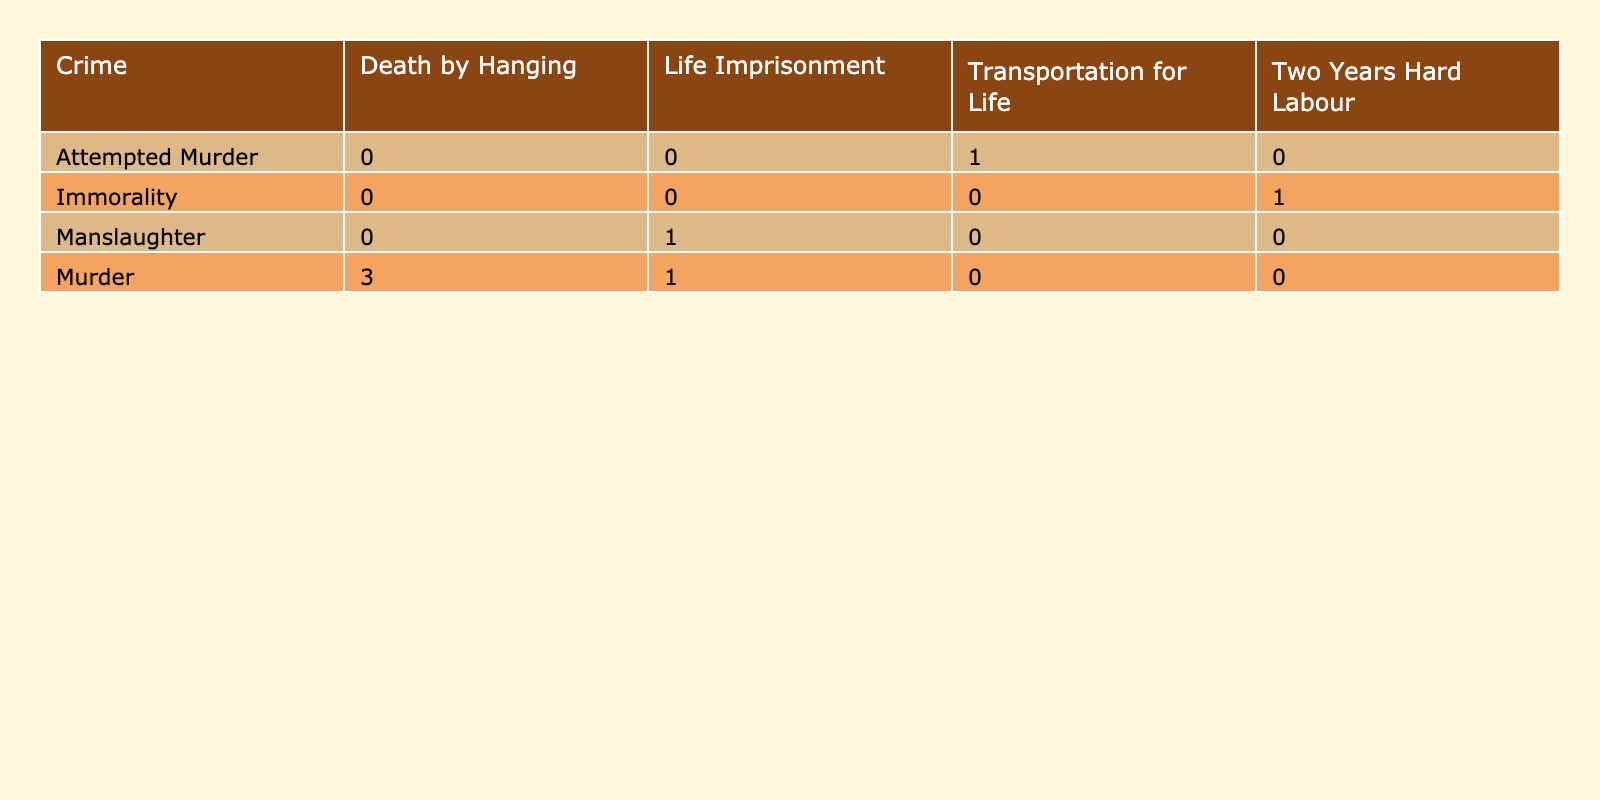What was the sentencing outcome for the murder trial of Dr. Hawley Crippen? The table shows that Dr. Hawley Crippen was found guilty of murder in 1910 and received the sentencing outcome of "Death by Hanging."
Answer: Death by Hanging How many defendants were sentenced to imprisonment for life? There are two defendants in the table who were sentenced to life imprisonment: George Wainwright and Florence Maybrick. Thus, the count is 2.
Answer: 2 Did any defendant receive transportation for life? By examining the table, it is evident that William Wainwright was sentenced to "Transportation for Life." Therefore, the answer is yes.
Answer: Yes What percentage of the crimes listed resulted in a death sentence? Of the eight trials listed, three resulted in a death sentence (Dr. Hawley Crippen, George Joseph Smith, Edward O'Neill). The percentage is calculated as (3/8) * 100 = 37.5%.
Answer: 37.5% Which crime had the most severe sentencing outcome? The most severe sentencing outcome listed in the table is "Death by Hanging," which applies to three different murder trials. Hence, the crime of murder had the most severe sentencing outcomes.
Answer: Murder 